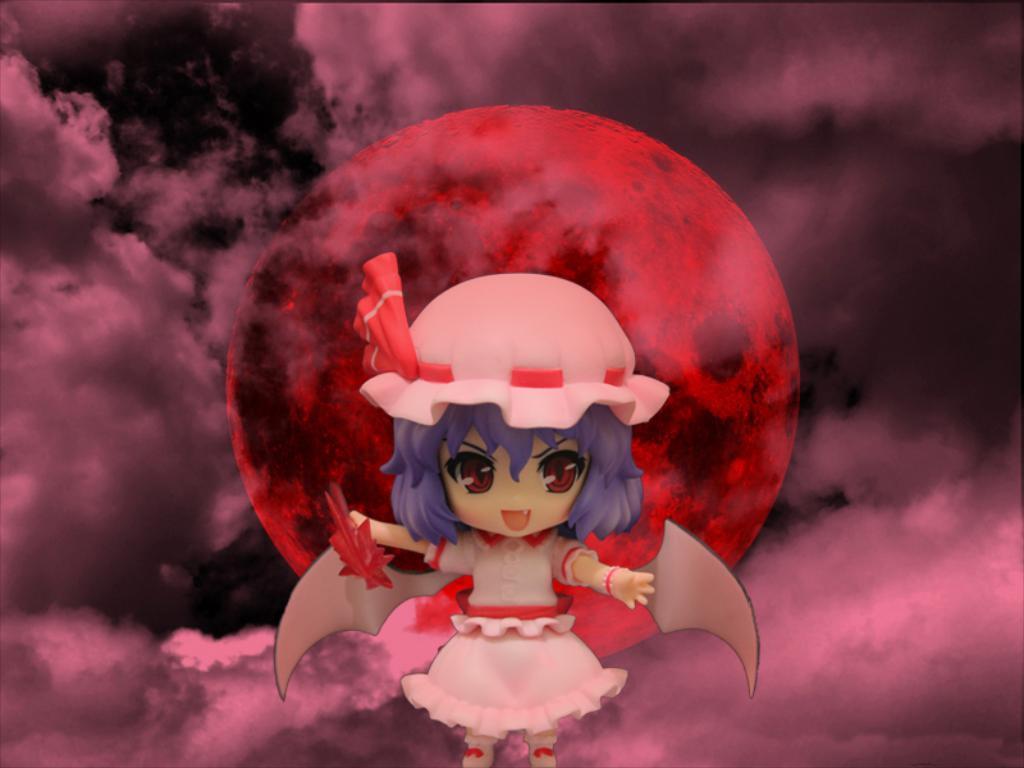Can you describe this image briefly? In this picture we can see a cartoon of a girl with wings. In the background, we can see a cloudy dark sky with orange sun. 